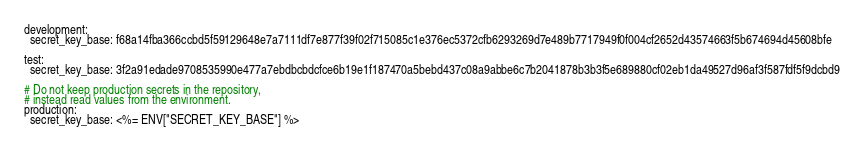Convert code to text. <code><loc_0><loc_0><loc_500><loc_500><_YAML_>
development:
  secret_key_base: f68a14fba366ccbd5f59129648e7a7111df7e877f39f02f715085c1e376ec5372cfb6293269d7e489b7717949f0f004cf2652d43574663f5b674694d45608bfe

test:
  secret_key_base: 3f2a91edade9708535990e477a7ebdbcbdcfce6b19e1f187470a5bebd437c08a9abbe6c7b2041878b3b3f5e689880cf02eb1da49527d96af3f587fdf5f9dcbd9

# Do not keep production secrets in the repository,
# instead read values from the environment.
production:
  secret_key_base: <%= ENV["SECRET_KEY_BASE"] %>
</code> 